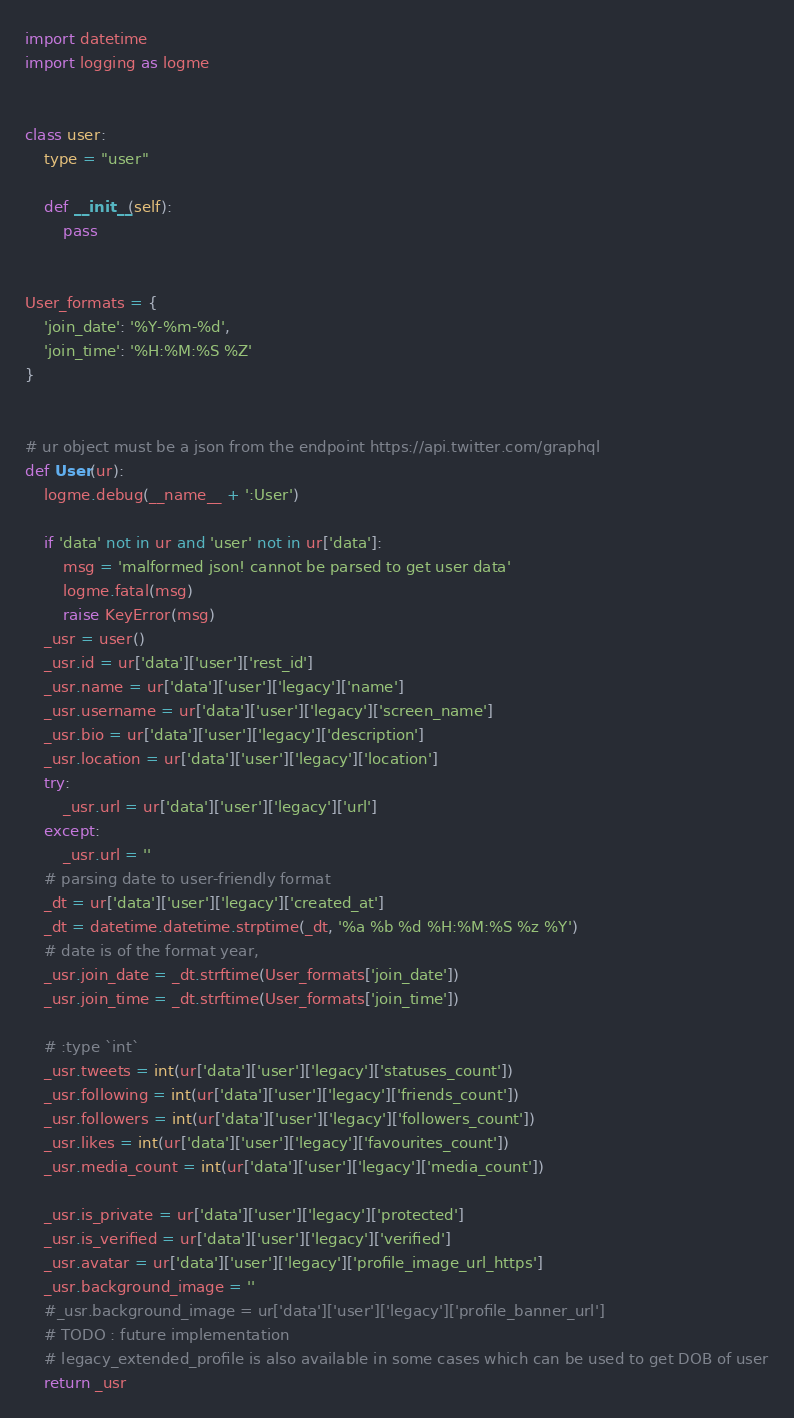<code> <loc_0><loc_0><loc_500><loc_500><_Python_>import datetime
import logging as logme


class user:
    type = "user"

    def __init__(self):
        pass


User_formats = {
    'join_date': '%Y-%m-%d',
    'join_time': '%H:%M:%S %Z'
}


# ur object must be a json from the endpoint https://api.twitter.com/graphql
def User(ur):
    logme.debug(__name__ + ':User')
  
    if 'data' not in ur and 'user' not in ur['data']:
        msg = 'malformed json! cannot be parsed to get user data'
        logme.fatal(msg)
        raise KeyError(msg)
    _usr = user()
    _usr.id = ur['data']['user']['rest_id']
    _usr.name = ur['data']['user']['legacy']['name']
    _usr.username = ur['data']['user']['legacy']['screen_name']
    _usr.bio = ur['data']['user']['legacy']['description']
    _usr.location = ur['data']['user']['legacy']['location']
    try:
        _usr.url = ur['data']['user']['legacy']['url']
    except:
        _usr.url = ''
    # parsing date to user-friendly format
    _dt = ur['data']['user']['legacy']['created_at']
    _dt = datetime.datetime.strptime(_dt, '%a %b %d %H:%M:%S %z %Y')
    # date is of the format year,
    _usr.join_date = _dt.strftime(User_formats['join_date'])
    _usr.join_time = _dt.strftime(User_formats['join_time'])

    # :type `int`
    _usr.tweets = int(ur['data']['user']['legacy']['statuses_count'])
    _usr.following = int(ur['data']['user']['legacy']['friends_count'])
    _usr.followers = int(ur['data']['user']['legacy']['followers_count'])
    _usr.likes = int(ur['data']['user']['legacy']['favourites_count'])
    _usr.media_count = int(ur['data']['user']['legacy']['media_count'])

    _usr.is_private = ur['data']['user']['legacy']['protected']
    _usr.is_verified = ur['data']['user']['legacy']['verified']
    _usr.avatar = ur['data']['user']['legacy']['profile_image_url_https']
    _usr.background_image = ''
    #_usr.background_image = ur['data']['user']['legacy']['profile_banner_url']
    # TODO : future implementation
    # legacy_extended_profile is also available in some cases which can be used to get DOB of user
    return _usr
</code> 